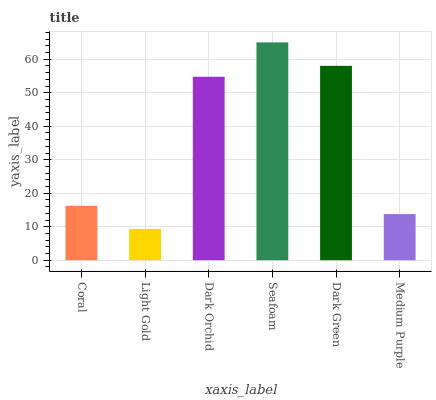Is Light Gold the minimum?
Answer yes or no. Yes. Is Seafoam the maximum?
Answer yes or no. Yes. Is Dark Orchid the minimum?
Answer yes or no. No. Is Dark Orchid the maximum?
Answer yes or no. No. Is Dark Orchid greater than Light Gold?
Answer yes or no. Yes. Is Light Gold less than Dark Orchid?
Answer yes or no. Yes. Is Light Gold greater than Dark Orchid?
Answer yes or no. No. Is Dark Orchid less than Light Gold?
Answer yes or no. No. Is Dark Orchid the high median?
Answer yes or no. Yes. Is Coral the low median?
Answer yes or no. Yes. Is Seafoam the high median?
Answer yes or no. No. Is Seafoam the low median?
Answer yes or no. No. 